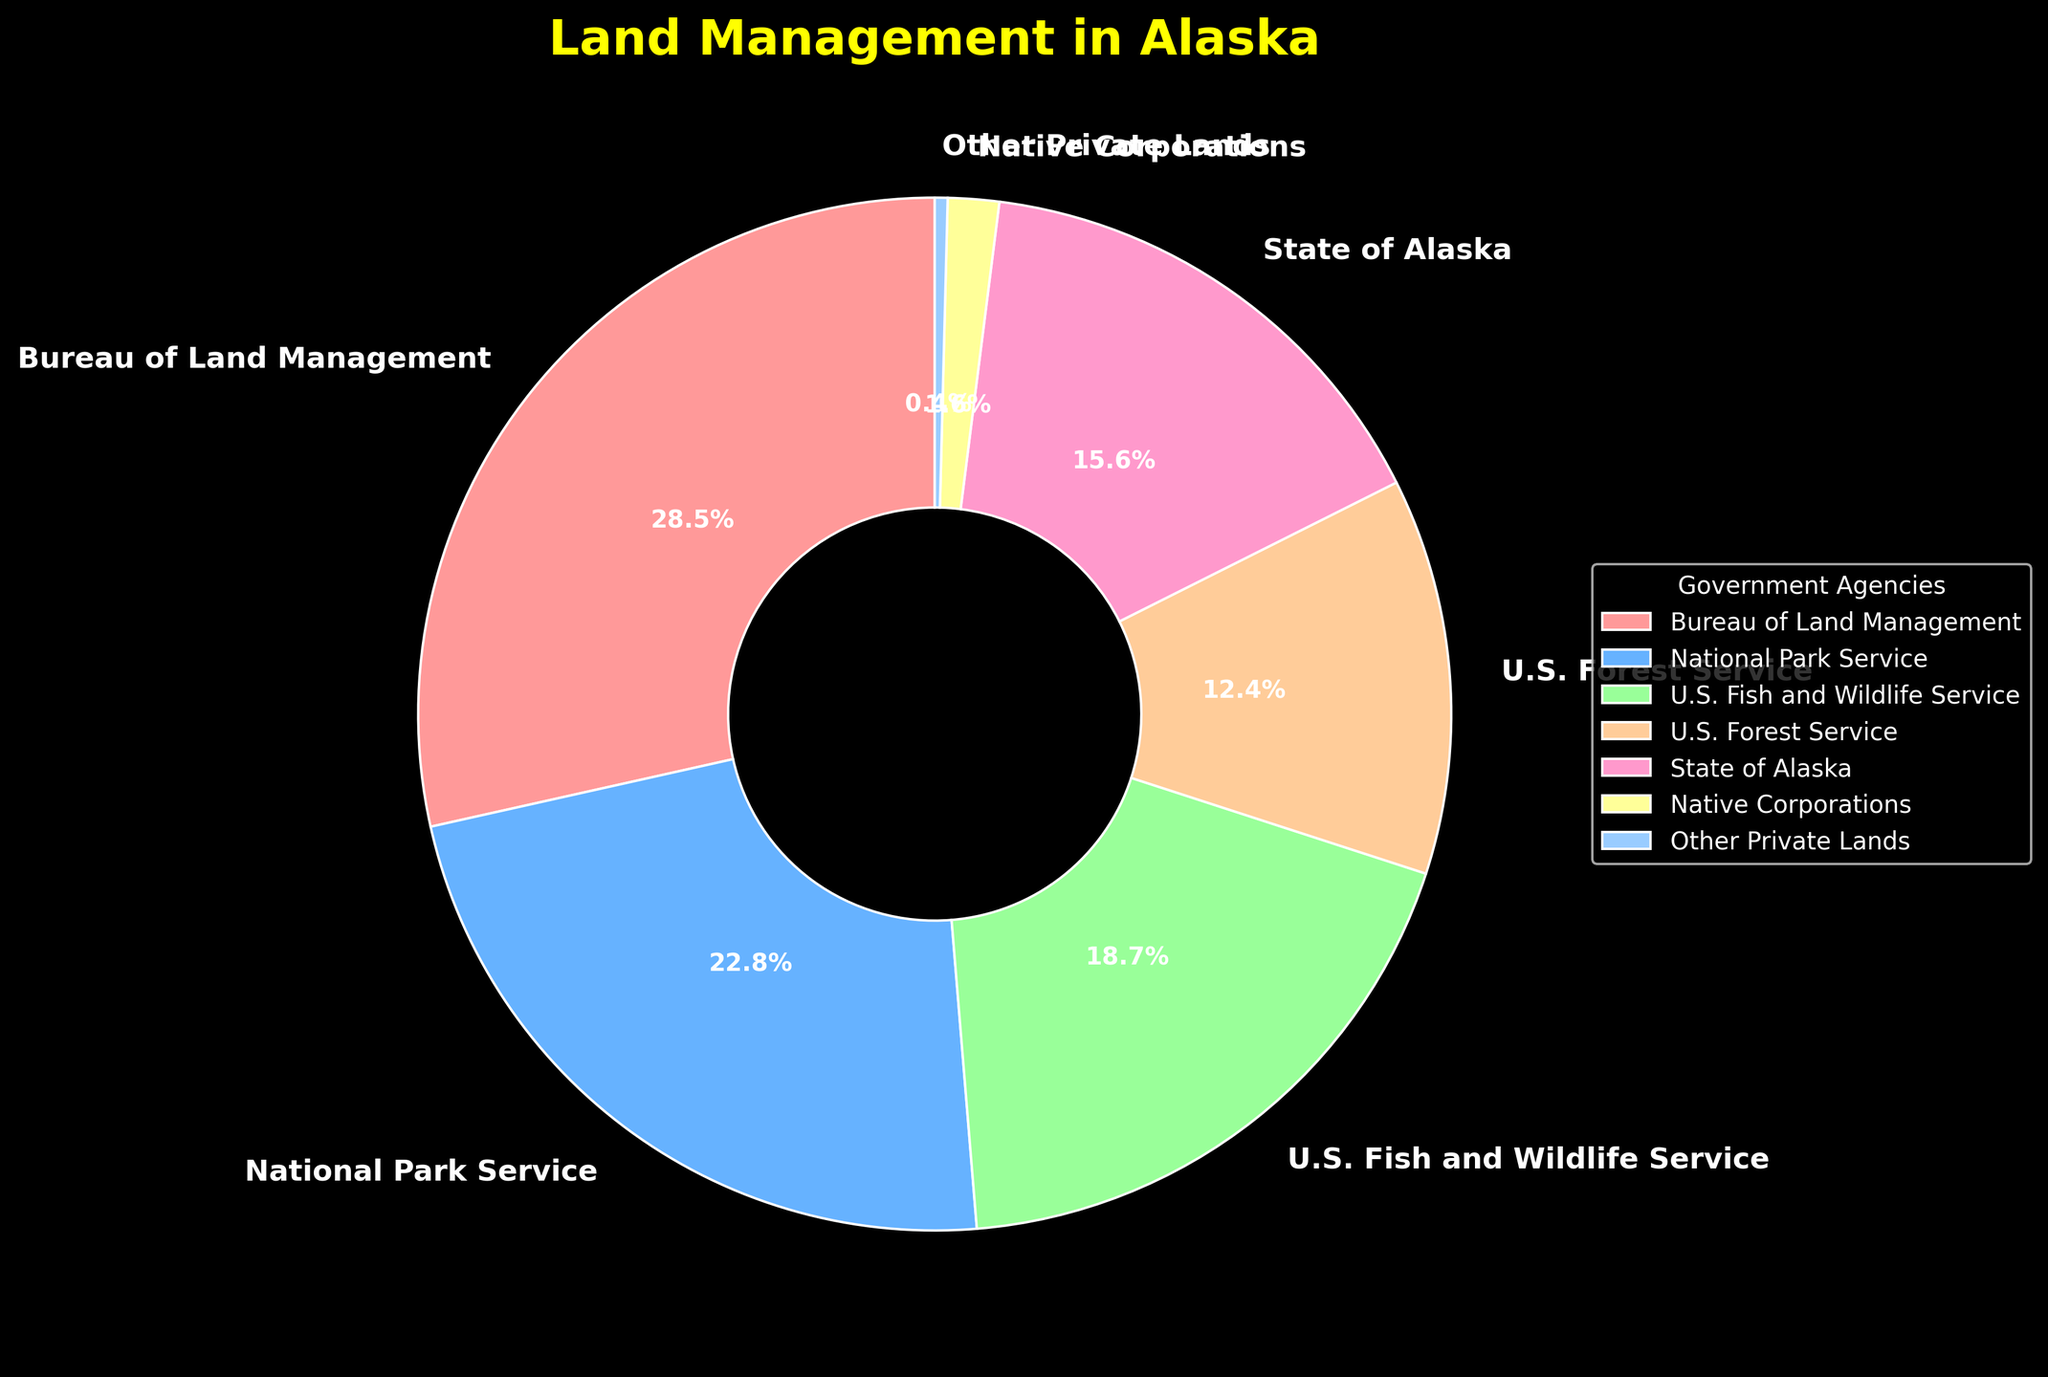what is the title of the chart? The title is displayed at the top of the pie chart in bold, yellow font. The exact wording of the title is specified in the data and coding instructions.
Answer: Land Management in Alaska Which agency manages the smallest proportion of Alaska’s land? By visually inspecting the pie chart, we can see the smallest segment of the chart, which is labeled with the respective agency.
Answer: Other Private Lands What proportion of Alaska's land is managed by the State of Alaska? Look at the pie chart and find the segment labeled "State of Alaska", then read the percentage value directly associated with it.
Answer: 15.6% How many agencies are represented in this pie chart? By counting the number of segments in the pie chart along with their labels, you can determine the number of agencies.
Answer: 7 Which two agencies combined manage more than half of Alaska’s land? To find this, look for the two largest segments. The segments representing "Bureau of Land Management" and "National Park Service" have the highest percentages. Adding their percentages (28.5% + 22.8%) confirms they manage over 50% together.
Answer: Bureau of Land Management and National Park Service What is the second largest proportion of land management, and which agency does it represent? Visually identify the sector with the second largest size and note the percentage and agency label associated with it.
Answer: 22.8%, National Park Service How much more land does the Bureau of Land Management manage compared to the U.S. Forest Service? Subtract the U.S. Forest Service's proportion from that of the Bureau of Land Management: 28.5% - 12.4% = 16.1%.
Answer: 16.1% Which agency manages more land: U.S. Fish and Wildlife Service or the State of Alaska? Compare the two sectors labeled "U.S. Fish and Wildlife Service" and "State of Alaska" and note their percentages. 18.7% is greater than 15.6%.
Answer: U.S. Fish and Wildlife Service What is the combined land management percentage for Native Corporations and Other Private Lands? Add the percentages for Native Corporations and Other Private Lands: 1.6% + 0.4% = 2%.
Answer: 2% What is the color used for the National Park Service segment in the pie chart? Identify the color of the segment corresponding to the National Park Service by looking at the color scheme and its matching label.
Answer: Light Blue 